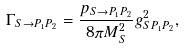Convert formula to latex. <formula><loc_0><loc_0><loc_500><loc_500>\Gamma _ { S \rightarrow P _ { 1 } P _ { 2 } } = \frac { p _ { S \rightarrow P _ { 1 } P _ { 2 } } } { 8 \pi M _ { S } ^ { 2 } } g _ { S P _ { 1 } P _ { 2 } } ^ { 2 } ,</formula> 